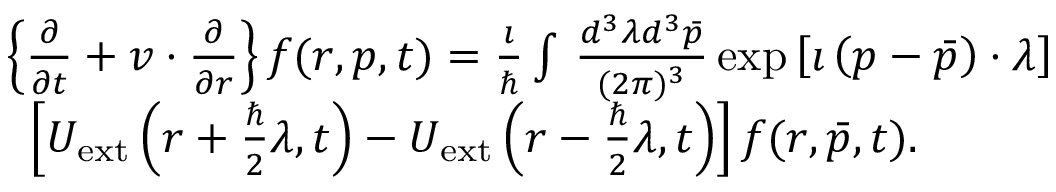<formula> <loc_0><loc_0><loc_500><loc_500>\begin{array} { r l } & { \left \{ \frac { \partial } { \partial { t } } + v \cdot \frac { \partial } { \partial r } \right \} f ( r , p , t ) = \frac { \imath } { } \int \, \frac { d ^ { 3 } \lambda { d } ^ { 3 } \bar { p } } { ( 2 \pi ) ^ { 3 } } \exp { \left [ \imath \left ( p - \bar { p } \right ) \cdot \lambda \right ] } } \\ & { \, \left [ U _ { e x t } \left ( r + \frac { } { 2 } \lambda , t \right ) - U _ { e x t } \left ( r - \frac { } { 2 } \lambda , t \right ) \right ] f ( r , \bar { p } , t ) . } \end{array}</formula> 